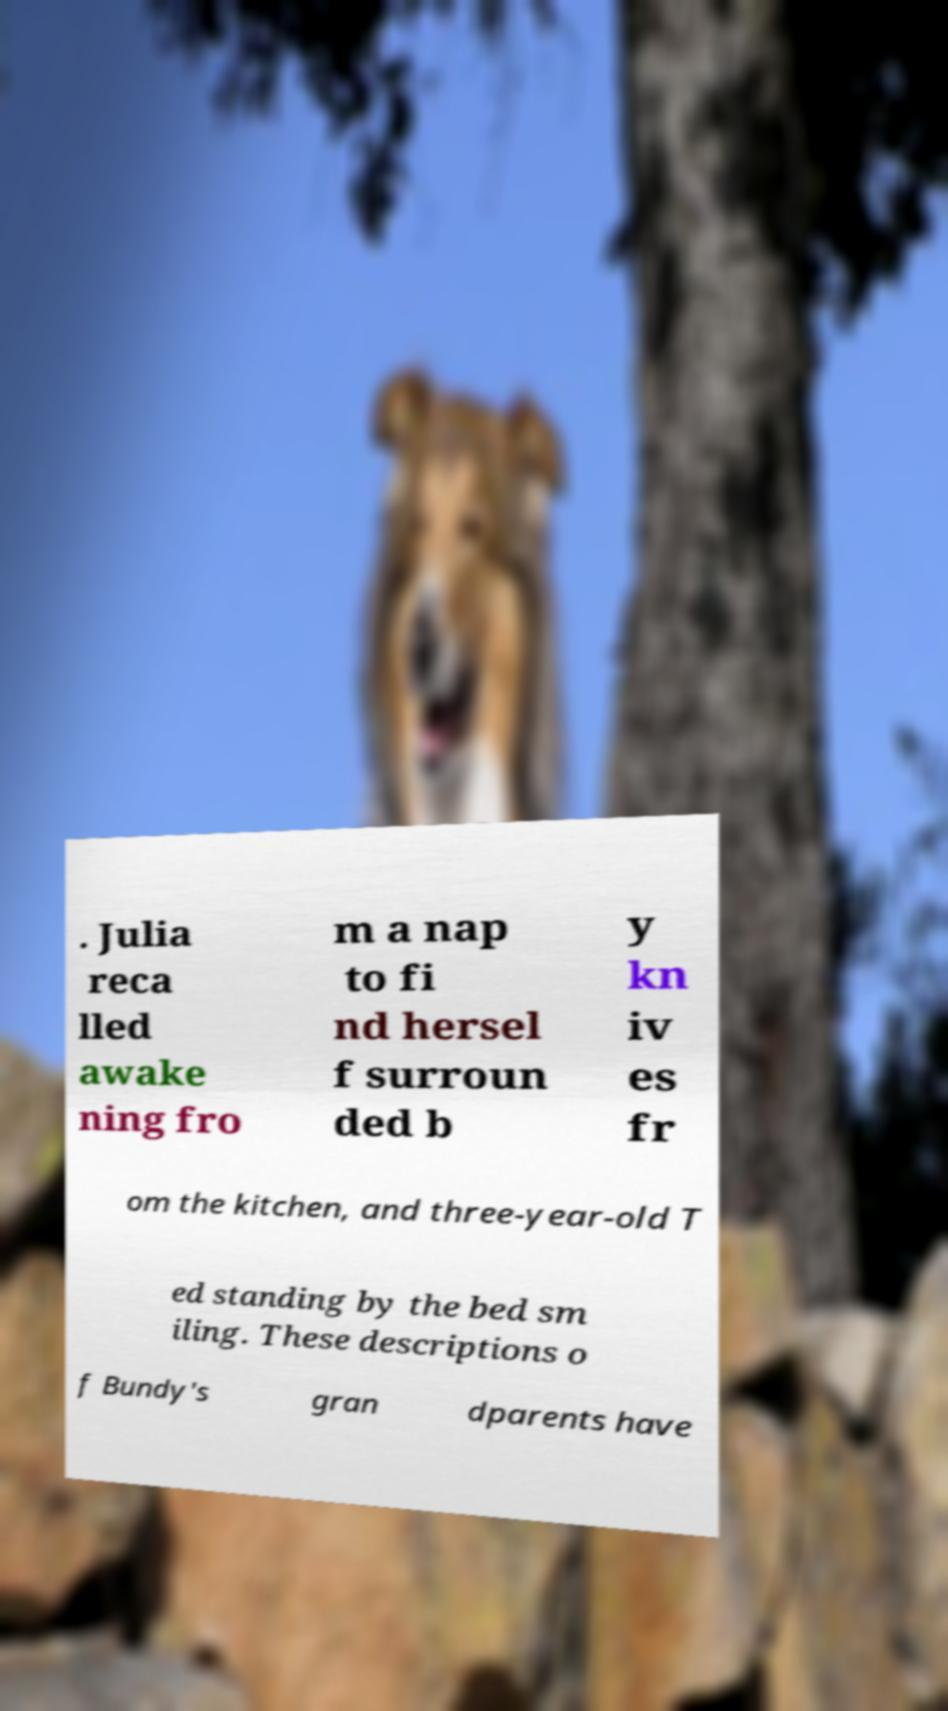There's text embedded in this image that I need extracted. Can you transcribe it verbatim? . Julia reca lled awake ning fro m a nap to fi nd hersel f surroun ded b y kn iv es fr om the kitchen, and three-year-old T ed standing by the bed sm iling. These descriptions o f Bundy's gran dparents have 